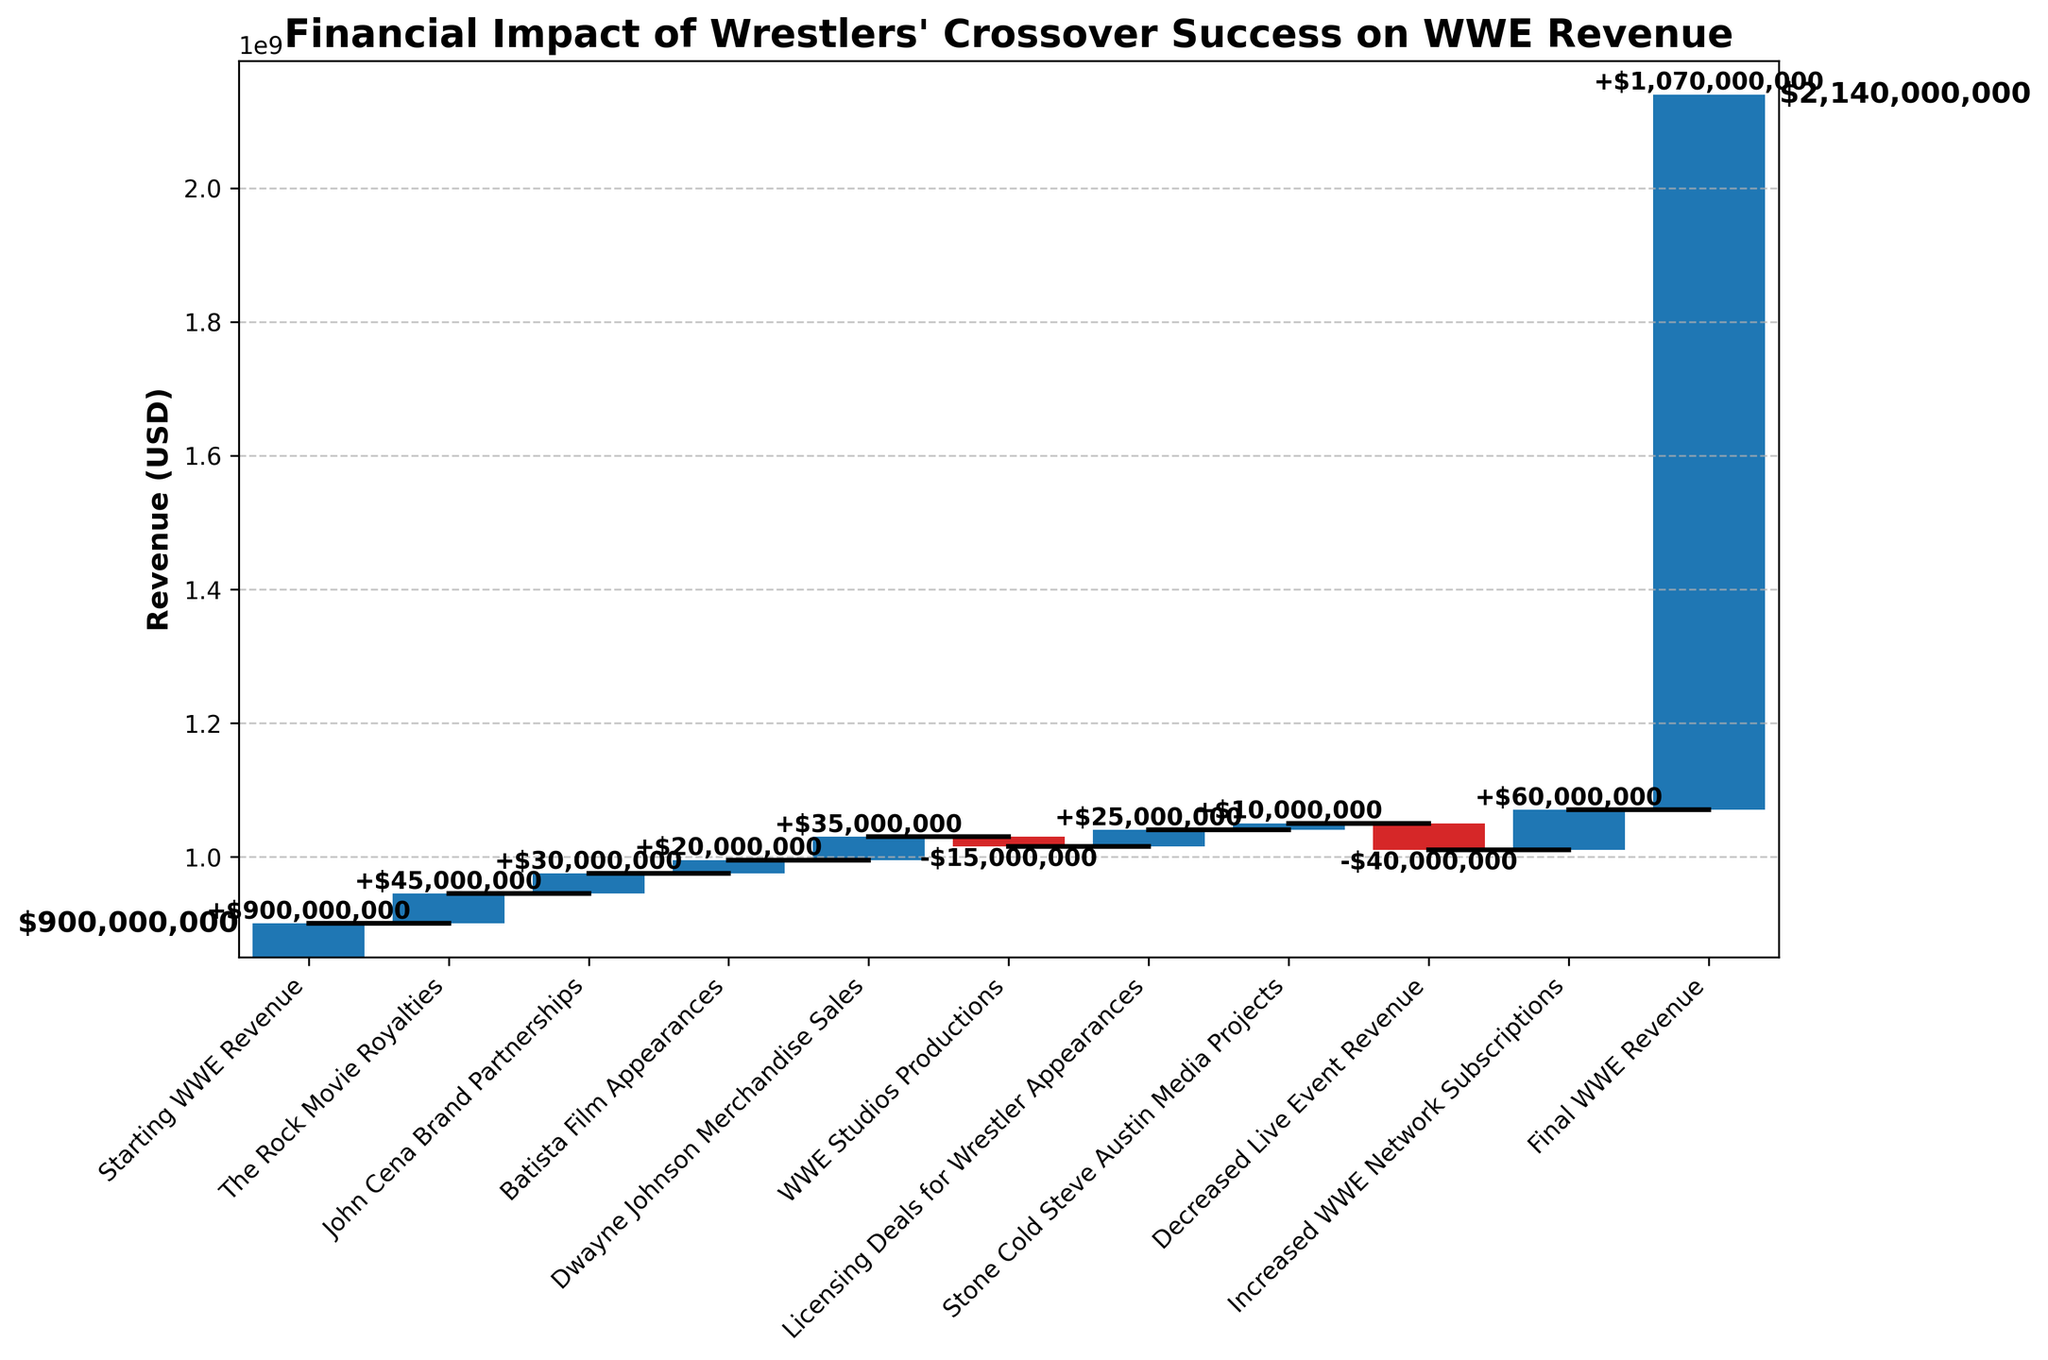What is the title of this chart? The title is displayed prominently at the top of the chart. It indicates the main idea or subject of the figure.
Answer: Financial Impact of Wrestlers' Crossover Success on WWE Revenue What is the starting WWE revenue? The first bar usually represents the starting point in a Waterfall Chart. It is labeled as 'Starting WWE Revenue'.
Answer: $900,000,000 Which category contributed the most to the WWE revenue? To determine the highest contribution, look for the longest positive bar in the chart. From the description, this corresponds to 'Increased WWE Network Subscriptions'.
Answer: $60,000,000 What is the final WWE revenue according to the chart? The final bar represents the ending value after accounting for all changes. It is labeled as 'Final WWE Revenue'.
Answer: $1,070,000,000 By how much did decreased live event revenue impact WWE revenue? Identify the bar labeled 'Decreased Live Event Revenue' and note its value. According to the data, it has a negative impact.
Answer: -$40,000,000 What is the cumulative revenue from 'The Rock Movie Royalties' and 'John Cena Brand Partnerships'? Add the values from both categories. The data shows $45,000,000 (The Rock Movie Royalties) + $30,000,000 (John Cena Brand Partnerships).
Answer: $75,000,000 Which category had the largest negative impact on WWE revenue? Compare the negative values and find the one with the largest absolute value. Here, it corresponds to 'Decreased Live Event Revenue' with -$40,000,000.
Answer: Decreased Live Event Revenue How much did WWE Studios Productions affect the revenue? Look for the category 'WWE Studios Productions' and check the corresponding bar length to see the value.
Answer: -$15,000,000 What is the total positive impact of all the listed categories except the starting revenue? Sum up all the positive values from the data: $45,000,000 (The Rock Movie Royalties) + $30,000,000 (John Cena Brand Partnerships) + $20,000,000 (Batista Film Appearances) + $35,000,000 (Dwayne Johnson Merchandise Sales) + $25,000,000 (Licensing Deals for Wrestler Appearances) + $10,000,000 (Stone Cold Steve Austin Media Projects) + $60,000,000 (Increased WWE Network Subscriptions)
Answer: $225,000,000 How does the impact of 'Dwayne Johnson Merchandise Sales' compare to 'Batista Film Appearances'? Compare the values of the two categories: $35,000,000 (Dwayne Johnson Merchandise Sales) vs $20,000,000 (Batista Film Appearances).
Answer: Dwayne Johnson Merchandise Sales is higher by $15,000,000 